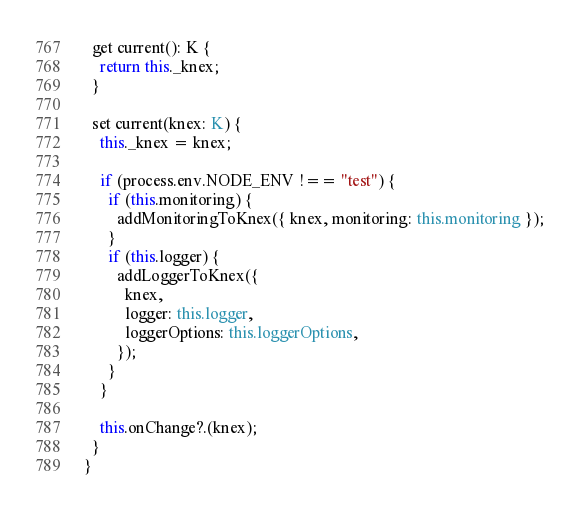Convert code to text. <code><loc_0><loc_0><loc_500><loc_500><_TypeScript_>
  get current(): K {
    return this._knex;
  }

  set current(knex: K) {
    this._knex = knex;

    if (process.env.NODE_ENV !== "test") {
      if (this.monitoring) {
        addMonitoringToKnex({ knex, monitoring: this.monitoring });
      }
      if (this.logger) {
        addLoggerToKnex({
          knex,
          logger: this.logger,
          loggerOptions: this.loggerOptions,
        });
      }
    }

    this.onChange?.(knex);
  }
}
</code> 